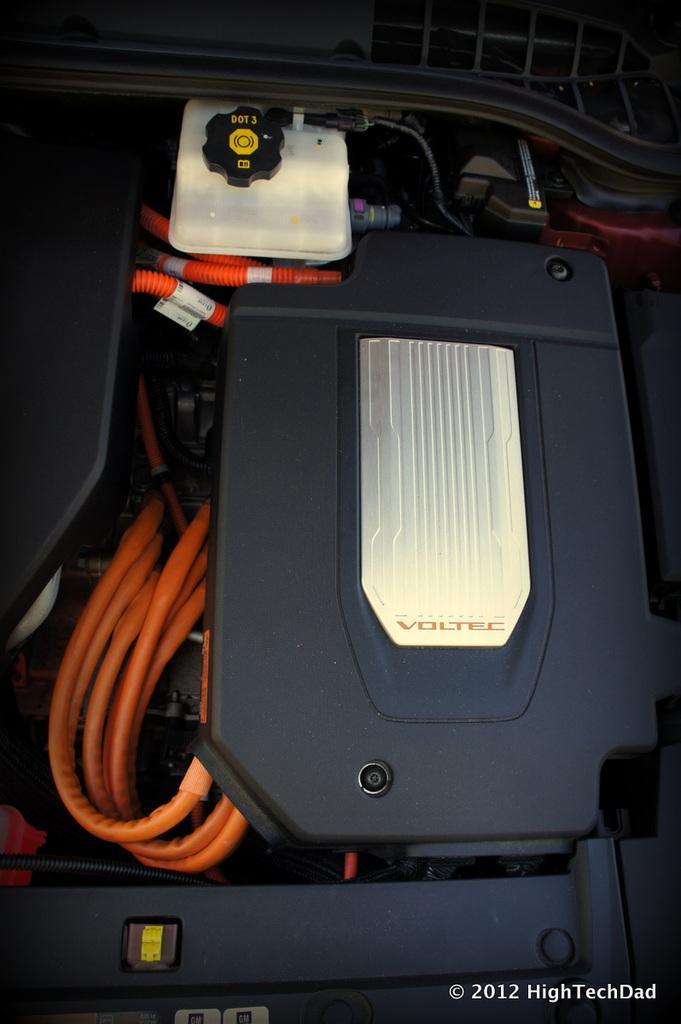Could you give a brief overview of what you see in this image? In this picture I can see a box with some wires. 